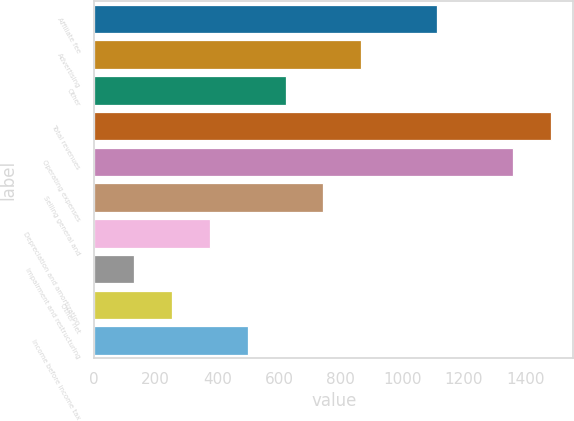Convert chart to OTSL. <chart><loc_0><loc_0><loc_500><loc_500><bar_chart><fcel>Affiliate fee<fcel>Advertising<fcel>Other<fcel>Total revenues<fcel>Operating expenses<fcel>Selling general and<fcel>Depreciation and amortization<fcel>Impairment and restructuring<fcel>Other net<fcel>Income before income tax<nl><fcel>1113.1<fcel>867.3<fcel>621.5<fcel>1481.8<fcel>1358.9<fcel>744.4<fcel>375.7<fcel>129.9<fcel>252.8<fcel>498.6<nl></chart> 